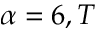<formula> <loc_0><loc_0><loc_500><loc_500>\alpha = 6 , T</formula> 